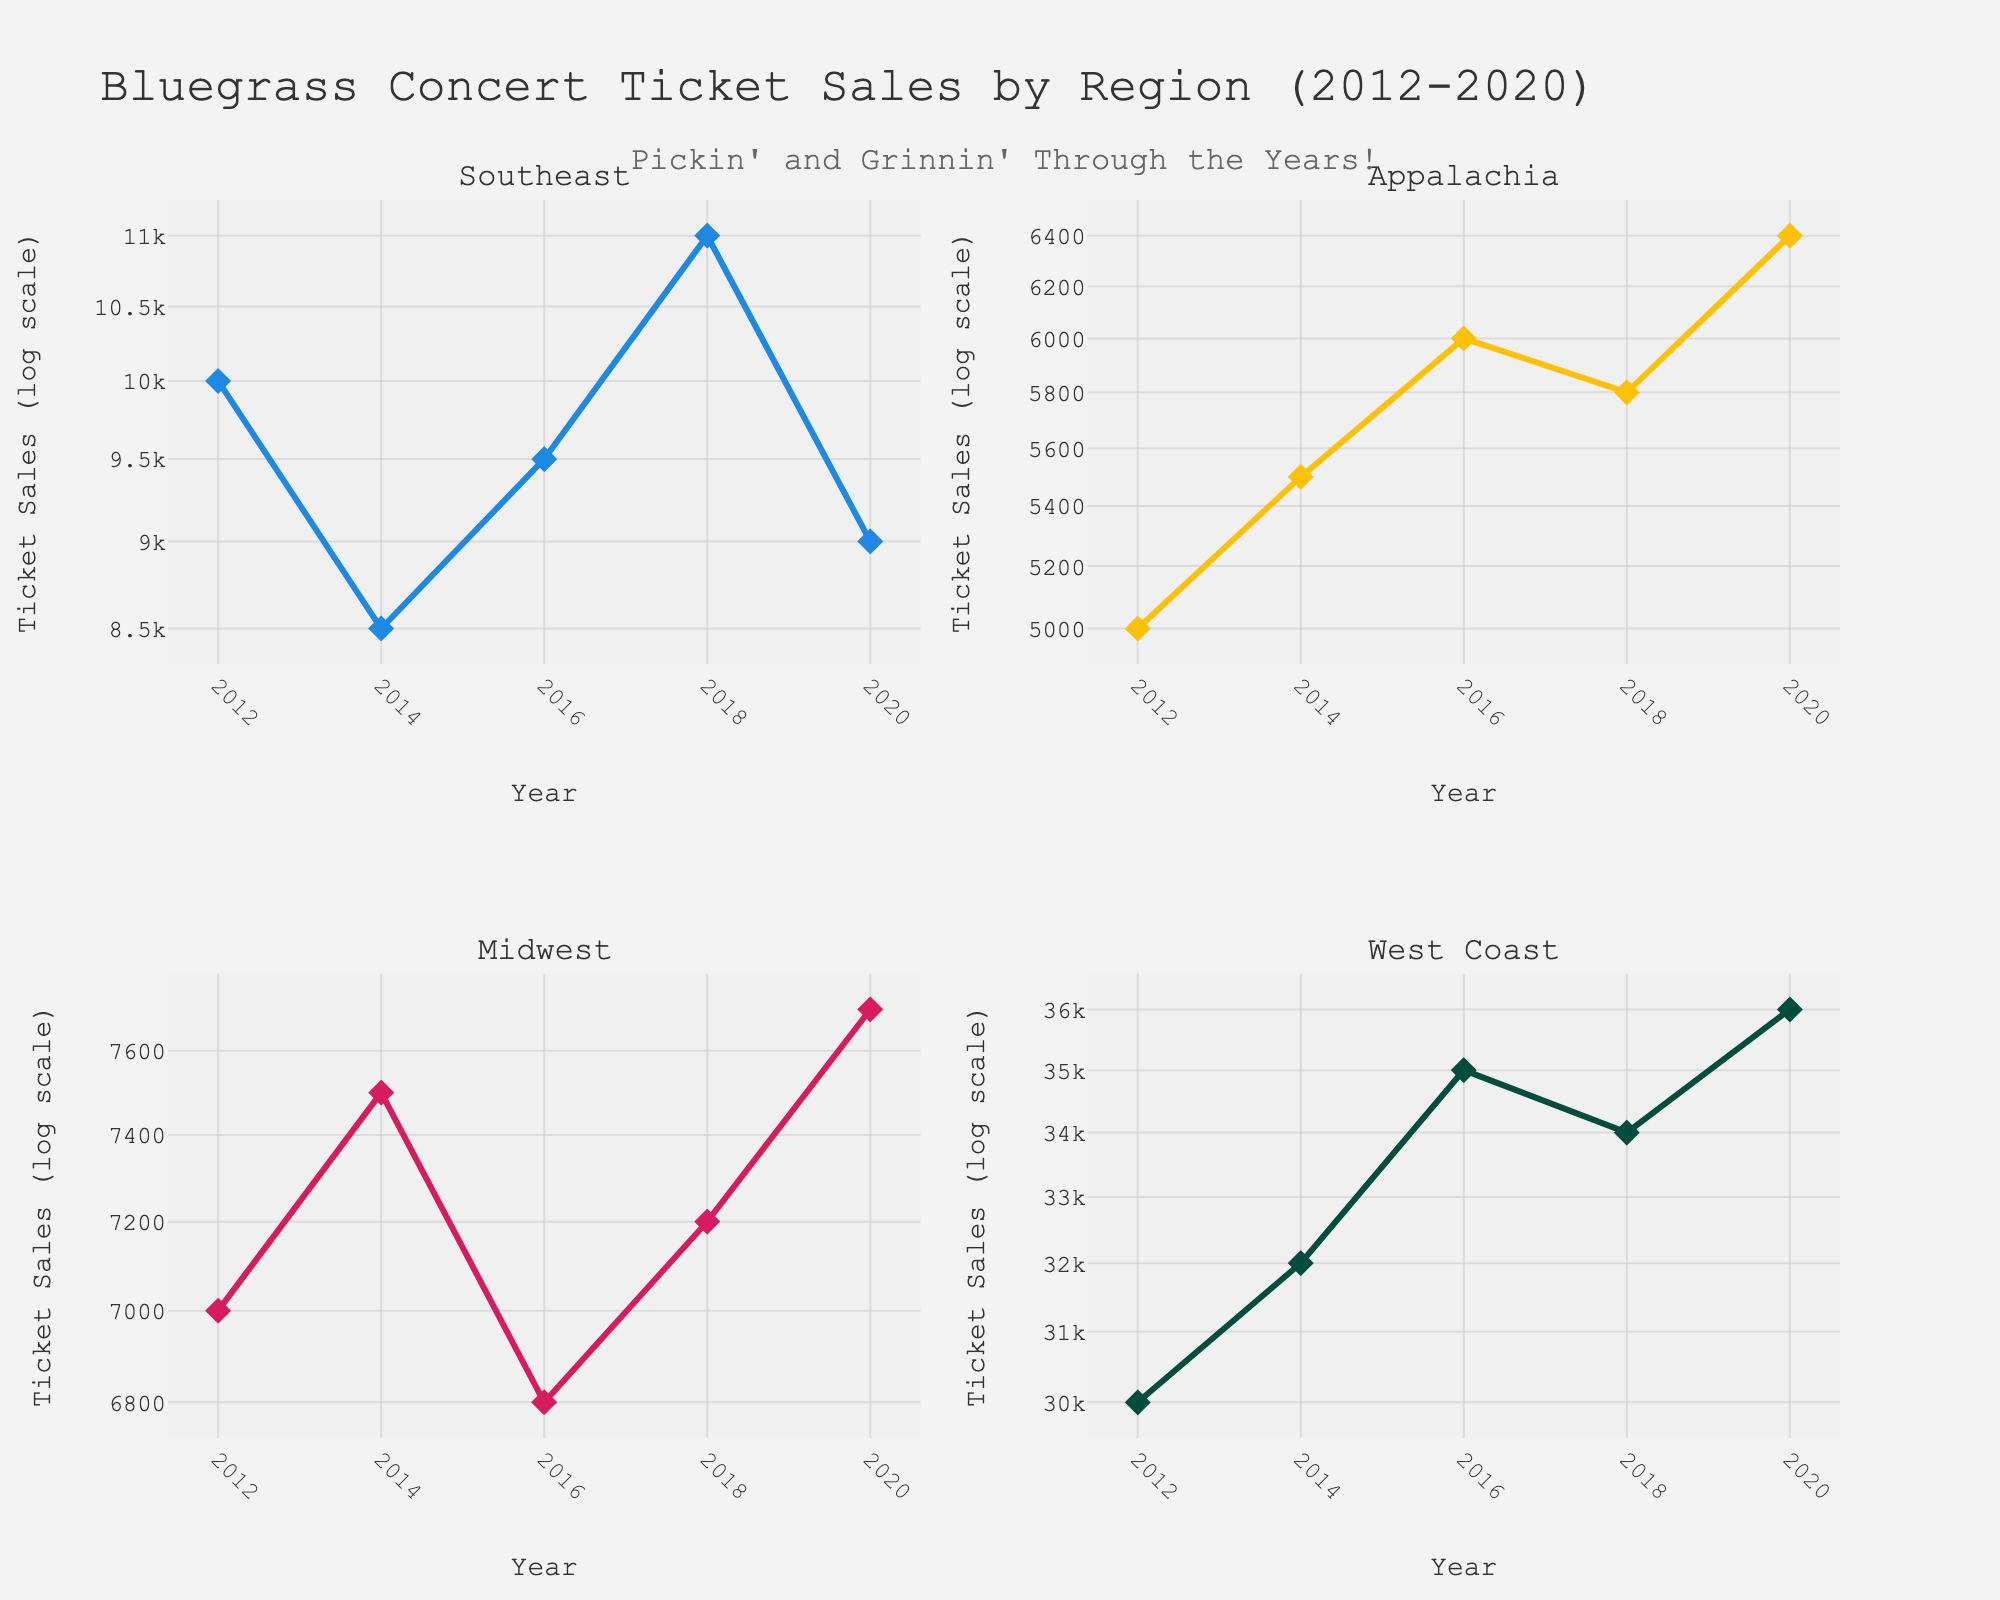Which region had the highest ticket sales in 2012? Look at the ticket sales values for each region in 2012. The West Coast region had the highest sales with 30,000 tickets.
Answer: West Coast What is the title of the plot? The title of the plot is located at the top center and reads "Bluegrass Concert Ticket Sales by Region (2012-2020)".
Answer: Bluegrass Concert Ticket Sales by Region (2012-2020) How many data points are there for the Midwest region? Each year provides one data point and there are records for the Midwest region from 2012 to 2020 (2012, 2014, 2016, 2018, 2020), making it a total of 5 data points.
Answer: 5 Which region experienced the largest overall increase in ticket sales from 2012 to 2020? Compare the ticket sales in 2012 and 2020 for each region. The West Coast shows the largest increase from 30,000 to 36,000 tickets.
Answer: West Coast Which region had a decrease in ticket sales from 2018 to 2020? Inspect the points between 2018 and 2020 for all regions. The Southeast region shows a decrease from 11,000 to 9,000 tickets.
Answer: Southeast Which region consistently had the lowest ticket sales across the years? By checking ticket sales for all years, the Appalachian region consistently had the lowest ticket numbers, even though it showed growth.
Answer: Appalachia What noticeable trend exists in the Southeast region’s ticket sales? The Southeast region saw fluctuation with an initial decrease from 2012 to 2014, followed by an increase until 2018, and a subsequent drop in 2020.
Answer: Fluctuation What is the average ticket sales value for the Midwest region over the years? Sum the ticket sales of the Midwest region (7000 + 7500 + 6800 + 7200 + 7700) which equals 36200, then divide by the 5 years: 36200 / 5 = 7240.
Answer: 7240 Which region saw ticket sales peak in 2016? By evaluating the 2016 ticket sales, the West Coast had the highest peak at 35,000 tickets.
Answer: West Coast How did the West Coast region's sales change from 2016 to 2018? The West Coast ticket sales slightly decreased from 35,000 in 2016 to 34,000 in 2018.
Answer: Decreased 